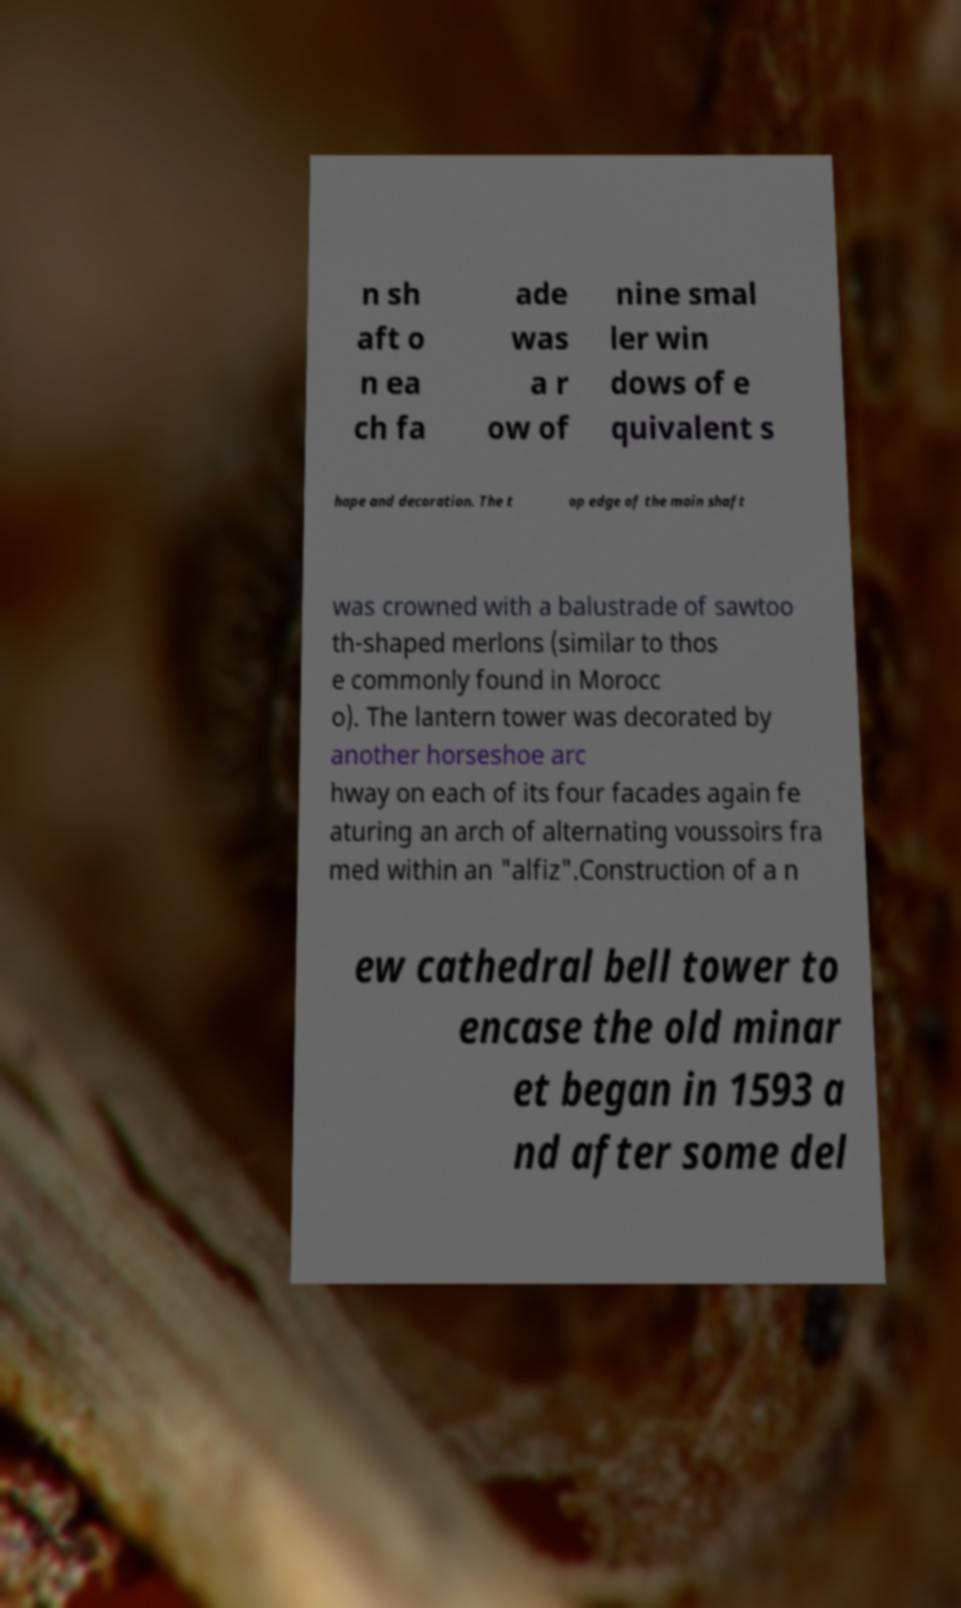Can you read and provide the text displayed in the image?This photo seems to have some interesting text. Can you extract and type it out for me? n sh aft o n ea ch fa ade was a r ow of nine smal ler win dows of e quivalent s hape and decoration. The t op edge of the main shaft was crowned with a balustrade of sawtoo th-shaped merlons (similar to thos e commonly found in Morocc o). The lantern tower was decorated by another horseshoe arc hway on each of its four facades again fe aturing an arch of alternating voussoirs fra med within an "alfiz".Construction of a n ew cathedral bell tower to encase the old minar et began in 1593 a nd after some del 